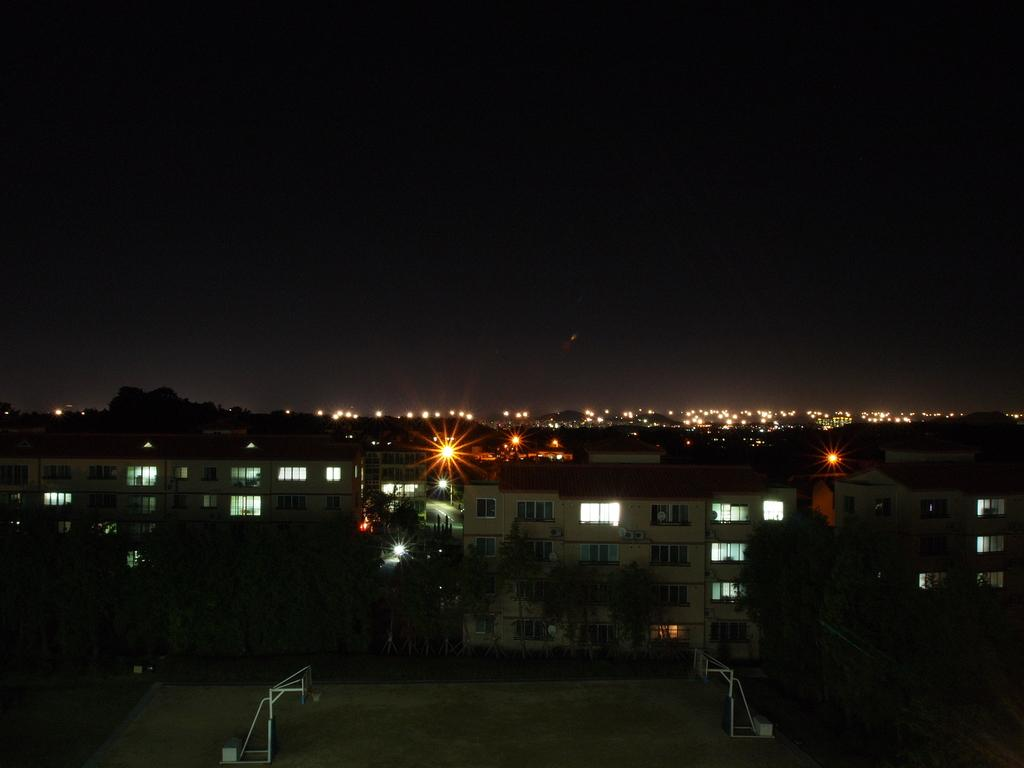At what time of day was the image taken? The image was taken at night time. What is the primary surface visible in the image? There is a ground in the image. What type of structures can be seen on the ground? There are two metal structures on the ground. What other elements are present in the image? There are buildings, trees, and lights visible in the image. How would you describe the overall lighting in the image? The background of the image is dark, but there are lights visible. What type of record can be heard playing in the background of the image? There is no record playing in the background of the image, as it is a still photograph. What sense is being stimulated by the image? The image primarily stimulates the sense of sight, as it is a visual representation. 